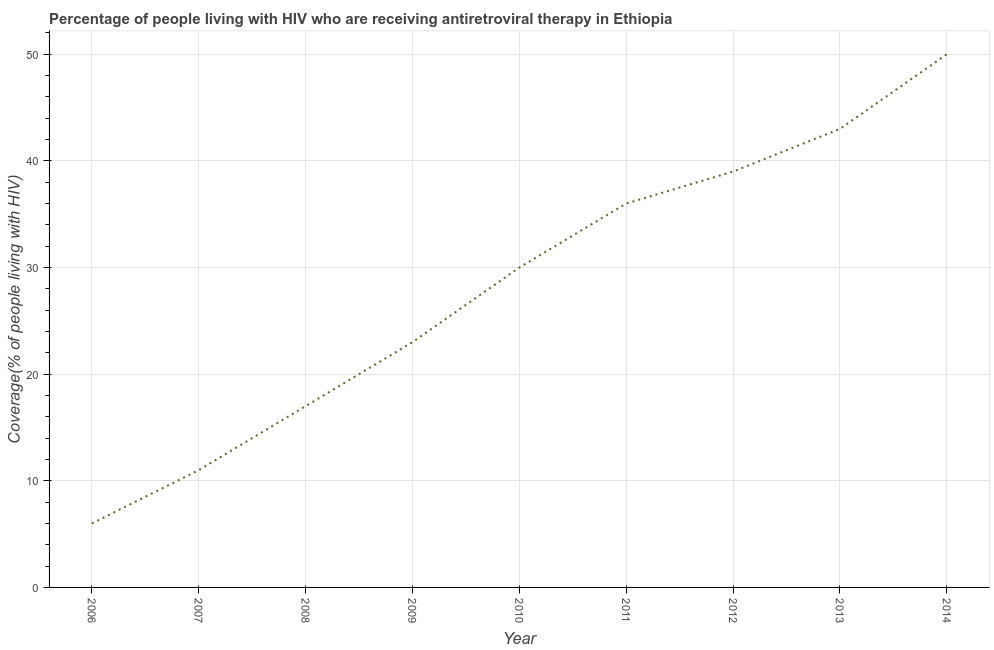What is the antiretroviral therapy coverage in 2010?
Give a very brief answer. 30. Across all years, what is the maximum antiretroviral therapy coverage?
Offer a terse response. 50. In which year was the antiretroviral therapy coverage maximum?
Offer a very short reply. 2014. In which year was the antiretroviral therapy coverage minimum?
Your answer should be very brief. 2006. What is the sum of the antiretroviral therapy coverage?
Ensure brevity in your answer.  255. What is the difference between the antiretroviral therapy coverage in 2008 and 2013?
Keep it short and to the point. -26. What is the average antiretroviral therapy coverage per year?
Your answer should be compact. 28.33. What is the median antiretroviral therapy coverage?
Your response must be concise. 30. In how many years, is the antiretroviral therapy coverage greater than 30 %?
Your answer should be very brief. 4. What is the ratio of the antiretroviral therapy coverage in 2011 to that in 2014?
Your answer should be very brief. 0.72. Is the difference between the antiretroviral therapy coverage in 2010 and 2012 greater than the difference between any two years?
Offer a very short reply. No. What is the difference between the highest and the second highest antiretroviral therapy coverage?
Give a very brief answer. 7. What is the difference between the highest and the lowest antiretroviral therapy coverage?
Give a very brief answer. 44. How many lines are there?
Keep it short and to the point. 1. Are the values on the major ticks of Y-axis written in scientific E-notation?
Keep it short and to the point. No. Does the graph contain any zero values?
Provide a short and direct response. No. What is the title of the graph?
Offer a very short reply. Percentage of people living with HIV who are receiving antiretroviral therapy in Ethiopia. What is the label or title of the X-axis?
Make the answer very short. Year. What is the label or title of the Y-axis?
Your answer should be compact. Coverage(% of people living with HIV). What is the Coverage(% of people living with HIV) of 2006?
Your response must be concise. 6. What is the Coverage(% of people living with HIV) of 2007?
Make the answer very short. 11. What is the Coverage(% of people living with HIV) in 2009?
Provide a short and direct response. 23. What is the Coverage(% of people living with HIV) of 2010?
Ensure brevity in your answer.  30. What is the Coverage(% of people living with HIV) in 2012?
Make the answer very short. 39. What is the difference between the Coverage(% of people living with HIV) in 2006 and 2007?
Give a very brief answer. -5. What is the difference between the Coverage(% of people living with HIV) in 2006 and 2008?
Make the answer very short. -11. What is the difference between the Coverage(% of people living with HIV) in 2006 and 2009?
Offer a very short reply. -17. What is the difference between the Coverage(% of people living with HIV) in 2006 and 2010?
Provide a succinct answer. -24. What is the difference between the Coverage(% of people living with HIV) in 2006 and 2012?
Your response must be concise. -33. What is the difference between the Coverage(% of people living with HIV) in 2006 and 2013?
Ensure brevity in your answer.  -37. What is the difference between the Coverage(% of people living with HIV) in 2006 and 2014?
Your answer should be very brief. -44. What is the difference between the Coverage(% of people living with HIV) in 2007 and 2008?
Your answer should be very brief. -6. What is the difference between the Coverage(% of people living with HIV) in 2007 and 2009?
Your answer should be very brief. -12. What is the difference between the Coverage(% of people living with HIV) in 2007 and 2010?
Offer a terse response. -19. What is the difference between the Coverage(% of people living with HIV) in 2007 and 2011?
Give a very brief answer. -25. What is the difference between the Coverage(% of people living with HIV) in 2007 and 2012?
Ensure brevity in your answer.  -28. What is the difference between the Coverage(% of people living with HIV) in 2007 and 2013?
Make the answer very short. -32. What is the difference between the Coverage(% of people living with HIV) in 2007 and 2014?
Offer a very short reply. -39. What is the difference between the Coverage(% of people living with HIV) in 2008 and 2009?
Provide a succinct answer. -6. What is the difference between the Coverage(% of people living with HIV) in 2008 and 2010?
Ensure brevity in your answer.  -13. What is the difference between the Coverage(% of people living with HIV) in 2008 and 2012?
Your response must be concise. -22. What is the difference between the Coverage(% of people living with HIV) in 2008 and 2013?
Offer a terse response. -26. What is the difference between the Coverage(% of people living with HIV) in 2008 and 2014?
Keep it short and to the point. -33. What is the difference between the Coverage(% of people living with HIV) in 2009 and 2010?
Your answer should be very brief. -7. What is the difference between the Coverage(% of people living with HIV) in 2009 and 2011?
Keep it short and to the point. -13. What is the difference between the Coverage(% of people living with HIV) in 2009 and 2012?
Make the answer very short. -16. What is the difference between the Coverage(% of people living with HIV) in 2010 and 2011?
Your answer should be compact. -6. What is the difference between the Coverage(% of people living with HIV) in 2010 and 2012?
Your response must be concise. -9. What is the difference between the Coverage(% of people living with HIV) in 2010 and 2014?
Your answer should be compact. -20. What is the difference between the Coverage(% of people living with HIV) in 2011 and 2012?
Offer a very short reply. -3. What is the difference between the Coverage(% of people living with HIV) in 2011 and 2014?
Make the answer very short. -14. What is the difference between the Coverage(% of people living with HIV) in 2012 and 2013?
Your response must be concise. -4. What is the difference between the Coverage(% of people living with HIV) in 2012 and 2014?
Offer a very short reply. -11. What is the difference between the Coverage(% of people living with HIV) in 2013 and 2014?
Offer a very short reply. -7. What is the ratio of the Coverage(% of people living with HIV) in 2006 to that in 2007?
Your answer should be very brief. 0.55. What is the ratio of the Coverage(% of people living with HIV) in 2006 to that in 2008?
Give a very brief answer. 0.35. What is the ratio of the Coverage(% of people living with HIV) in 2006 to that in 2009?
Your answer should be compact. 0.26. What is the ratio of the Coverage(% of people living with HIV) in 2006 to that in 2011?
Make the answer very short. 0.17. What is the ratio of the Coverage(% of people living with HIV) in 2006 to that in 2012?
Provide a short and direct response. 0.15. What is the ratio of the Coverage(% of people living with HIV) in 2006 to that in 2013?
Keep it short and to the point. 0.14. What is the ratio of the Coverage(% of people living with HIV) in 2006 to that in 2014?
Ensure brevity in your answer.  0.12. What is the ratio of the Coverage(% of people living with HIV) in 2007 to that in 2008?
Provide a succinct answer. 0.65. What is the ratio of the Coverage(% of people living with HIV) in 2007 to that in 2009?
Your response must be concise. 0.48. What is the ratio of the Coverage(% of people living with HIV) in 2007 to that in 2010?
Offer a terse response. 0.37. What is the ratio of the Coverage(% of people living with HIV) in 2007 to that in 2011?
Provide a short and direct response. 0.31. What is the ratio of the Coverage(% of people living with HIV) in 2007 to that in 2012?
Ensure brevity in your answer.  0.28. What is the ratio of the Coverage(% of people living with HIV) in 2007 to that in 2013?
Provide a succinct answer. 0.26. What is the ratio of the Coverage(% of people living with HIV) in 2007 to that in 2014?
Offer a terse response. 0.22. What is the ratio of the Coverage(% of people living with HIV) in 2008 to that in 2009?
Make the answer very short. 0.74. What is the ratio of the Coverage(% of people living with HIV) in 2008 to that in 2010?
Offer a terse response. 0.57. What is the ratio of the Coverage(% of people living with HIV) in 2008 to that in 2011?
Your response must be concise. 0.47. What is the ratio of the Coverage(% of people living with HIV) in 2008 to that in 2012?
Give a very brief answer. 0.44. What is the ratio of the Coverage(% of people living with HIV) in 2008 to that in 2013?
Your answer should be compact. 0.4. What is the ratio of the Coverage(% of people living with HIV) in 2008 to that in 2014?
Offer a very short reply. 0.34. What is the ratio of the Coverage(% of people living with HIV) in 2009 to that in 2010?
Make the answer very short. 0.77. What is the ratio of the Coverage(% of people living with HIV) in 2009 to that in 2011?
Give a very brief answer. 0.64. What is the ratio of the Coverage(% of people living with HIV) in 2009 to that in 2012?
Give a very brief answer. 0.59. What is the ratio of the Coverage(% of people living with HIV) in 2009 to that in 2013?
Your answer should be compact. 0.54. What is the ratio of the Coverage(% of people living with HIV) in 2009 to that in 2014?
Your response must be concise. 0.46. What is the ratio of the Coverage(% of people living with HIV) in 2010 to that in 2011?
Provide a succinct answer. 0.83. What is the ratio of the Coverage(% of people living with HIV) in 2010 to that in 2012?
Provide a short and direct response. 0.77. What is the ratio of the Coverage(% of people living with HIV) in 2010 to that in 2013?
Ensure brevity in your answer.  0.7. What is the ratio of the Coverage(% of people living with HIV) in 2011 to that in 2012?
Offer a very short reply. 0.92. What is the ratio of the Coverage(% of people living with HIV) in 2011 to that in 2013?
Your response must be concise. 0.84. What is the ratio of the Coverage(% of people living with HIV) in 2011 to that in 2014?
Offer a very short reply. 0.72. What is the ratio of the Coverage(% of people living with HIV) in 2012 to that in 2013?
Give a very brief answer. 0.91. What is the ratio of the Coverage(% of people living with HIV) in 2012 to that in 2014?
Your answer should be very brief. 0.78. What is the ratio of the Coverage(% of people living with HIV) in 2013 to that in 2014?
Give a very brief answer. 0.86. 